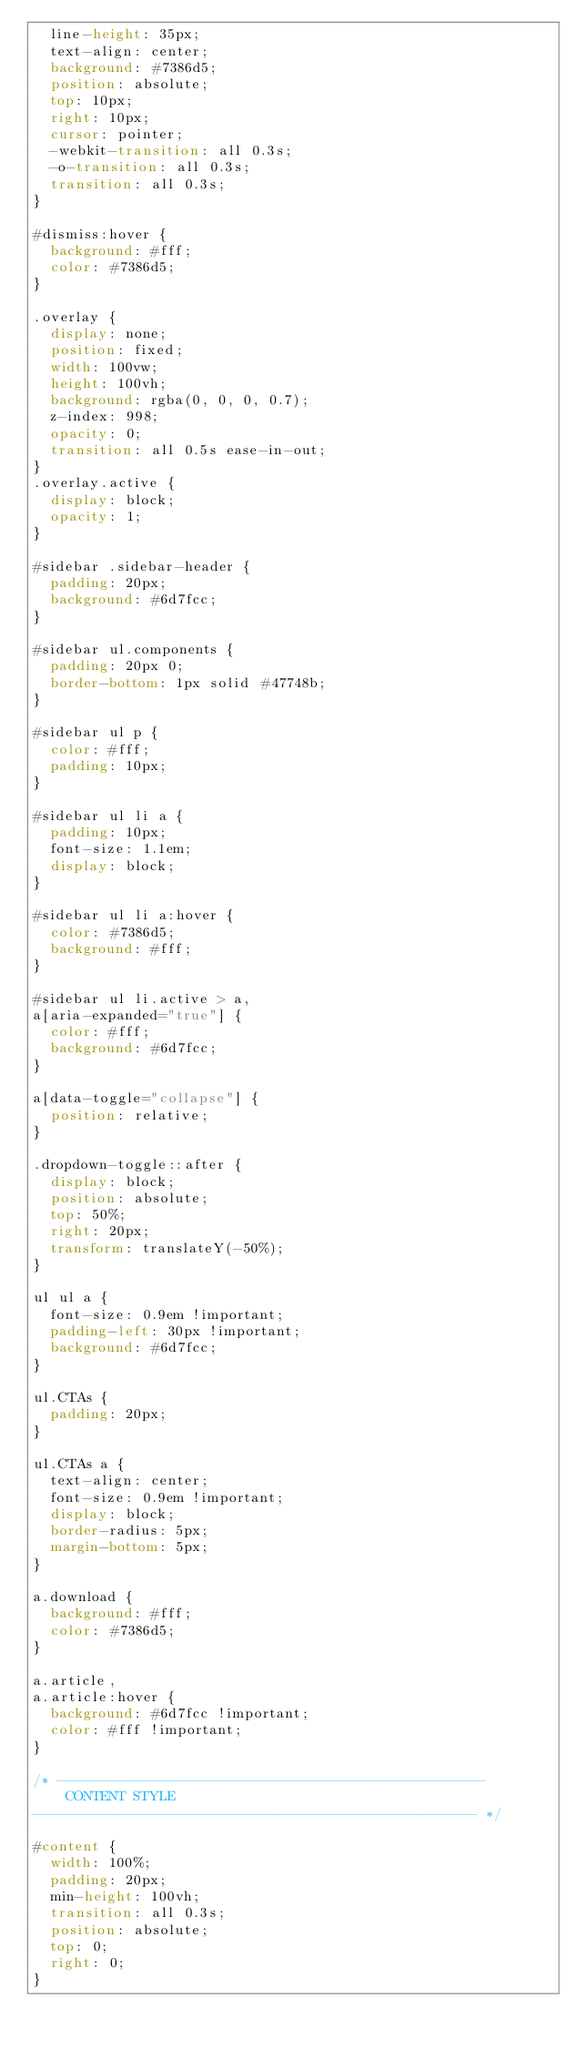<code> <loc_0><loc_0><loc_500><loc_500><_CSS_>  line-height: 35px;
  text-align: center;
  background: #7386d5;
  position: absolute;
  top: 10px;
  right: 10px;
  cursor: pointer;
  -webkit-transition: all 0.3s;
  -o-transition: all 0.3s;
  transition: all 0.3s;
}

#dismiss:hover {
  background: #fff;
  color: #7386d5;
}

.overlay {
  display: none;
  position: fixed;
  width: 100vw;
  height: 100vh;
  background: rgba(0, 0, 0, 0.7);
  z-index: 998;
  opacity: 0;
  transition: all 0.5s ease-in-out;
}
.overlay.active {
  display: block;
  opacity: 1;
}

#sidebar .sidebar-header {
  padding: 20px;
  background: #6d7fcc;
}

#sidebar ul.components {
  padding: 20px 0;
  border-bottom: 1px solid #47748b;
}

#sidebar ul p {
  color: #fff;
  padding: 10px;
}

#sidebar ul li a {
  padding: 10px;
  font-size: 1.1em;
  display: block;
}

#sidebar ul li a:hover {
  color: #7386d5;
  background: #fff;
}

#sidebar ul li.active > a,
a[aria-expanded="true"] {
  color: #fff;
  background: #6d7fcc;
}

a[data-toggle="collapse"] {
  position: relative;
}

.dropdown-toggle::after {
  display: block;
  position: absolute;
  top: 50%;
  right: 20px;
  transform: translateY(-50%);
}

ul ul a {
  font-size: 0.9em !important;
  padding-left: 30px !important;
  background: #6d7fcc;
}

ul.CTAs {
  padding: 20px;
}

ul.CTAs a {
  text-align: center;
  font-size: 0.9em !important;
  display: block;
  border-radius: 5px;
  margin-bottom: 5px;
}

a.download {
  background: #fff;
  color: #7386d5;
}

a.article,
a.article:hover {
  background: #6d7fcc !important;
  color: #fff !important;
}

/* ---------------------------------------------------
    CONTENT STYLE
----------------------------------------------------- */

#content {
  width: 100%;
  padding: 20px;
  min-height: 100vh;
  transition: all 0.3s;
  position: absolute;
  top: 0;
  right: 0;
}
</code> 